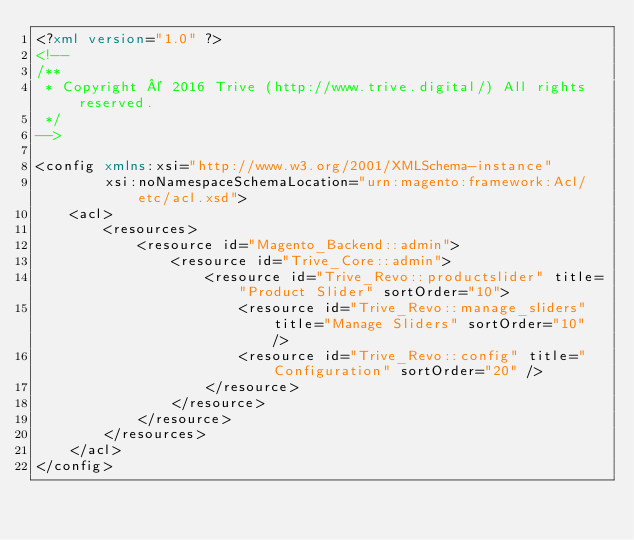<code> <loc_0><loc_0><loc_500><loc_500><_XML_><?xml version="1.0" ?>
<!--
/**
 * Copyright © 2016 Trive (http://www.trive.digital/) All rights reserved.
 */
-->

<config xmlns:xsi="http://www.w3.org/2001/XMLSchema-instance"
        xsi:noNamespaceSchemaLocation="urn:magento:framework:Acl/etc/acl.xsd">
    <acl>
        <resources>
            <resource id="Magento_Backend::admin">
                <resource id="Trive_Core::admin">
                    <resource id="Trive_Revo::productslider" title="Product Slider" sortOrder="10">
                        <resource id="Trive_Revo::manage_sliders" title="Manage Sliders" sortOrder="10" />
                        <resource id="Trive_Revo::config" title="Configuration" sortOrder="20" />
                    </resource>
                </resource>
            </resource>
        </resources>
    </acl>
</config></code> 